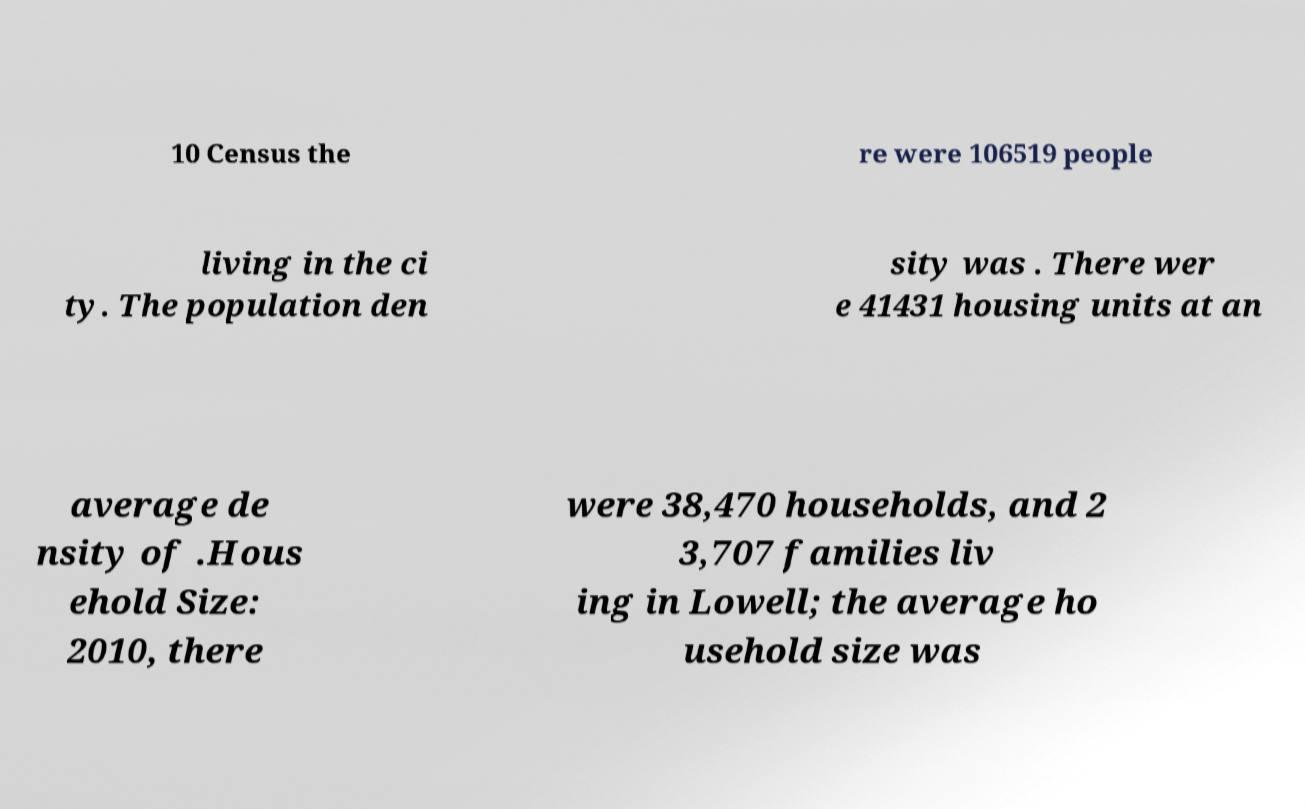Could you extract and type out the text from this image? 10 Census the re were 106519 people living in the ci ty. The population den sity was . There wer e 41431 housing units at an average de nsity of .Hous ehold Size: 2010, there were 38,470 households, and 2 3,707 families liv ing in Lowell; the average ho usehold size was 